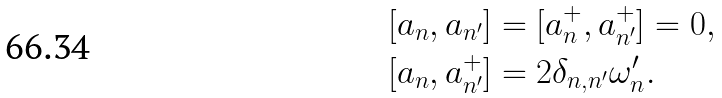<formula> <loc_0><loc_0><loc_500><loc_500>[ a _ { n } , a _ { n ^ { \prime } } ] & = [ a _ { n } ^ { + } , a _ { n ^ { \prime } } ^ { + } ] = 0 , \\ [ a _ { n } , a _ { n ^ { \prime } } ^ { + } ] & = 2 \delta _ { n , n ^ { \prime } } { \omega ^ { \prime } _ { n } } .</formula> 